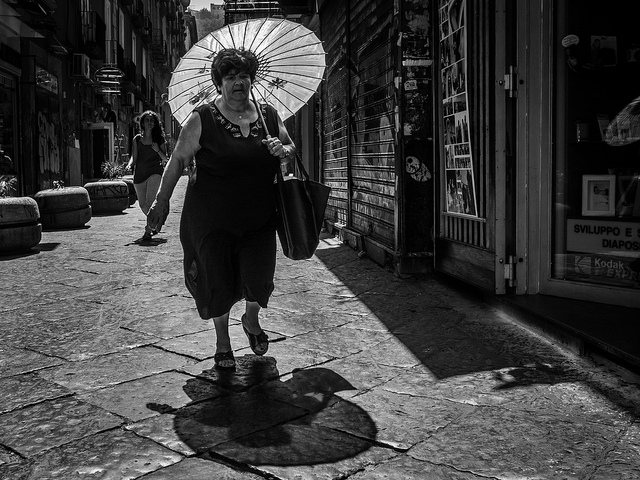Identify the text displayed in this image. Kodak SVILUPPO E DIAPOS 